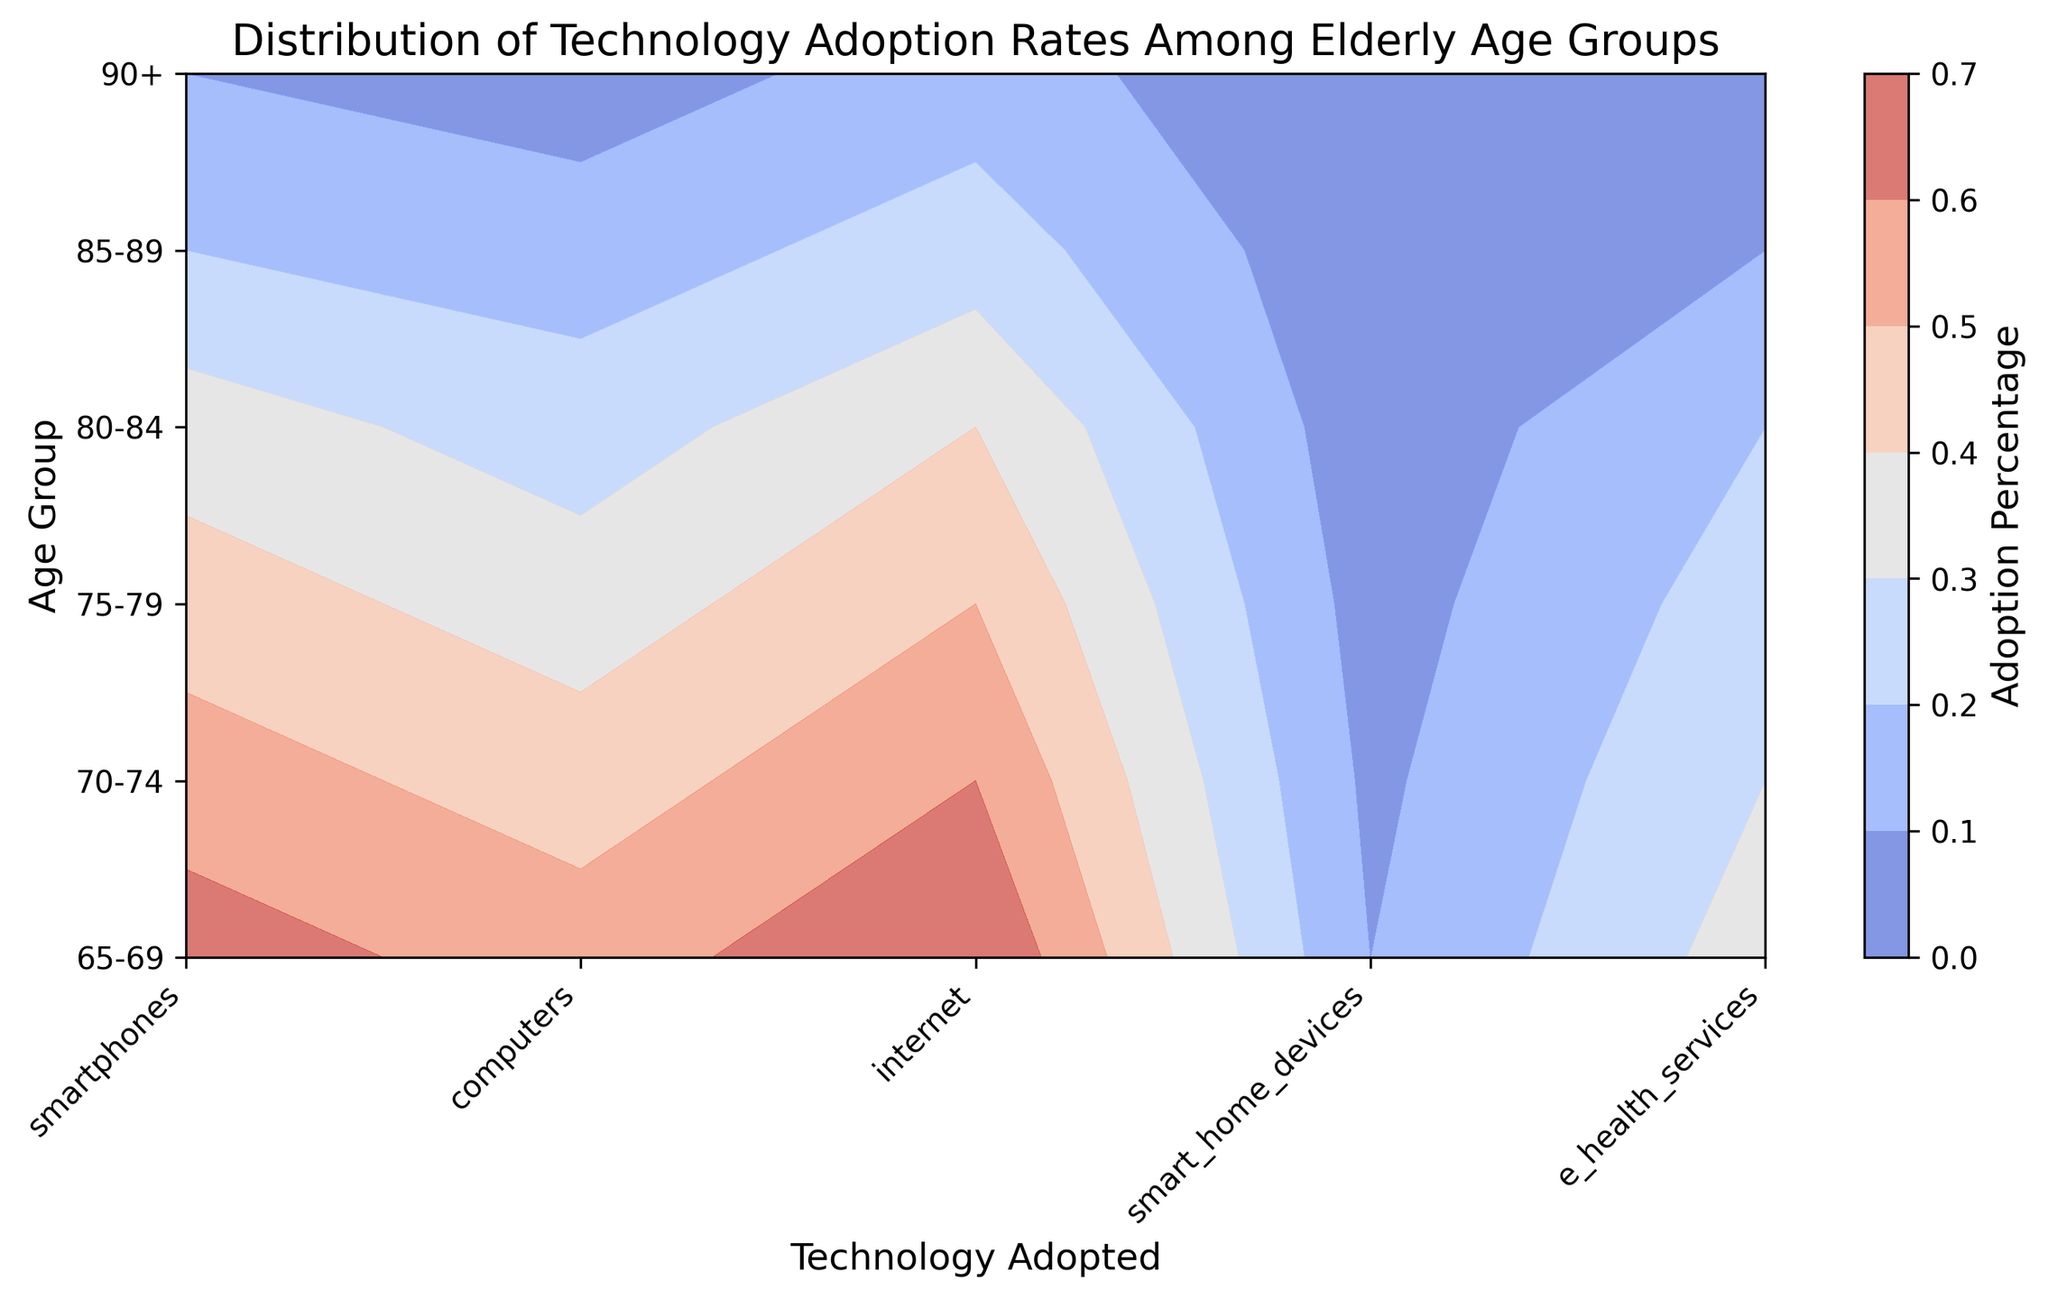Which age group has the highest adoption rate for smartphones? By examining the contour plot, find the highest color intensity under the 'smartphones' column which corresponds to the age group '65-69'. This is where the highest adoption rate is concentrated.
Answer: 65-69 Which technology shows the lowest adoption rate across all age groups? Look for the technology with the lightest shade of color across all age groups. 'smart_home_devices' consistently shows the lowest levels of adoption, indicating lower rates across all age groups.
Answer: smart_home_devices How does the adoption of computers compare between the age groups of 70-74 and 80-84? Compare the shades of colors under the 'computers' column for the age groups '70-74' and '80-84'. The '70-74' group has a darker shade, indicating higher adoption rates compared to '80-84'.
Answer: 70-74 has higher adoption than 80-84 What is the difference in internet adoption rates between the youngest (65-69) and the oldest (90+) age groups? Identify the color shades for 'internet' in age groups '65-69' and '90+'. The 65-69 group shows a much darker shade compared to the 90+ group. The specific adoption rates are 70% for 65-69 and 15% for 90+. The difference is 70% - 15% = 55%.
Answer: 55% What average adoption rate can be observed for e-health services across all age groups? To find the average adoption rate for 'e_health_services', sum up the adoption rates (35%, 30%, 25%, 20%, 10%, and 5%) and then divide by 6 (the number of age groups), 35+30+25+20+10+5 = 125. So, 125/6 ≈ 20.83%.
Answer: ~20.83% Among the technologies adopted by the 80-84 age group, which one is the second most popular? For the age group '80-84', list all adoption percentages and identify the second highest value. The values are 35% (smartphones), 25% (computers), 40% (internet), 4% (smart_home_devices), and 20% (e_health_services). The second highest rate is for 'smartphones' at 35%.
Answer: smartphones Which technology shows the most significant decline in adoption rates from the 65-69 to the 90+ age groups? Examine each technology's adoption rates from '65-69' to '90+', calculate the decline: smartphones (65% to 10%), computers (55% to 5%), internet (70% to 15%), smart_home_devices (10% to 1%), e_health_services (35% to 5%). The highest decline is in 'smartphones' (65% - 10% = 55%).
Answer: smartphones Is there any age group where the adoption rate of e-health services is higher than that of computers? If so, which group? Compare the 'e_health_services' and 'computers' adoption rates for each age group. The '75-79' age group shows 'e_health_services' (25%) higher than 'computers' (35%) and similarly for '65-69'. Therefore, the answer is 'non-applicable'.
Answer: non-applicable 